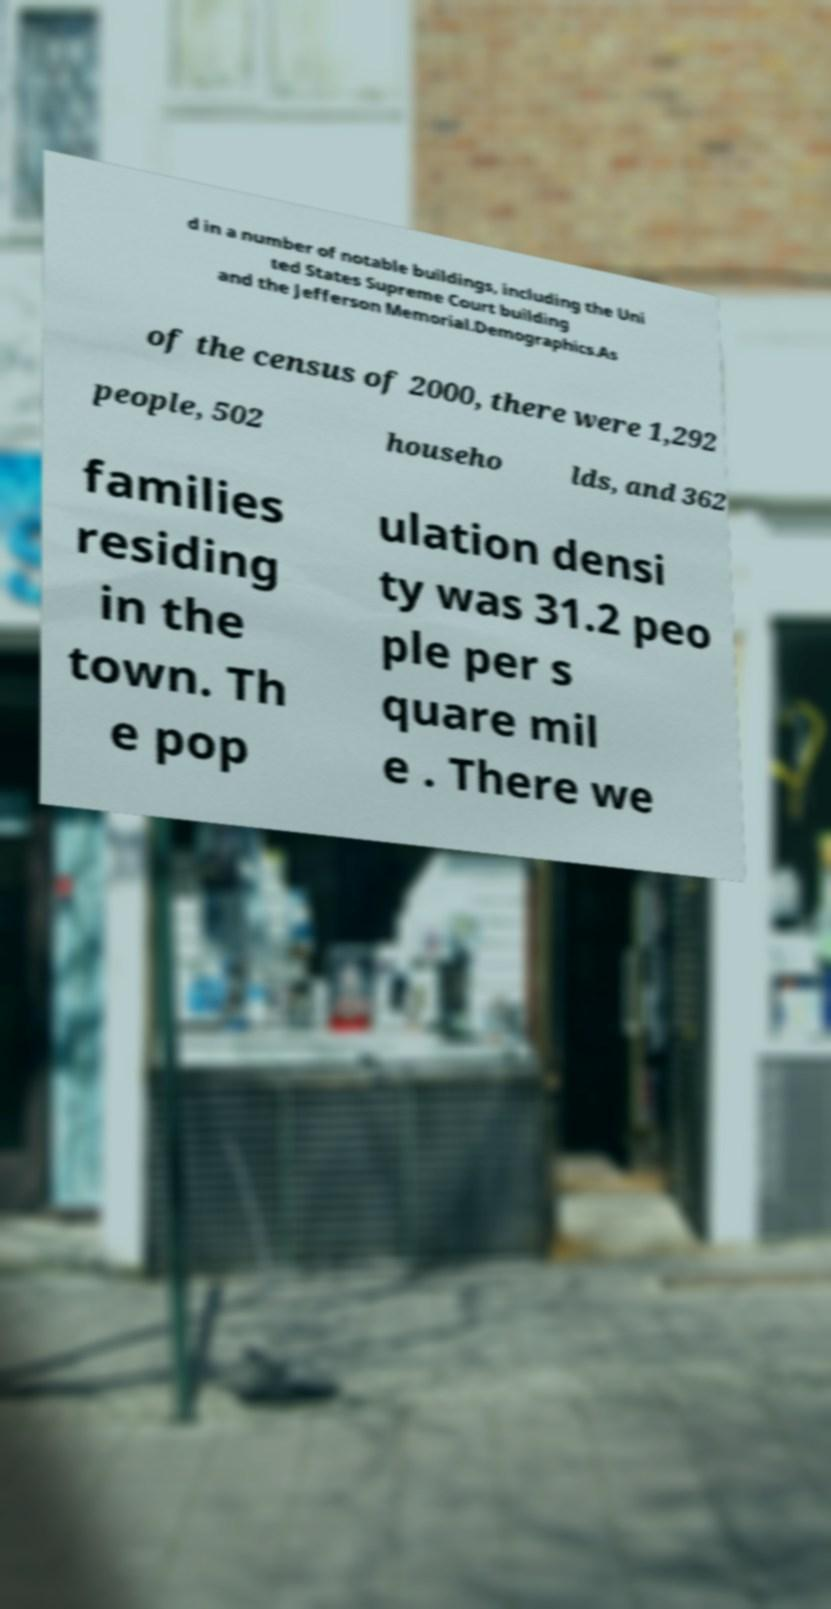What messages or text are displayed in this image? I need them in a readable, typed format. d in a number of notable buildings, including the Uni ted States Supreme Court building and the Jefferson Memorial.Demographics.As of the census of 2000, there were 1,292 people, 502 househo lds, and 362 families residing in the town. Th e pop ulation densi ty was 31.2 peo ple per s quare mil e . There we 